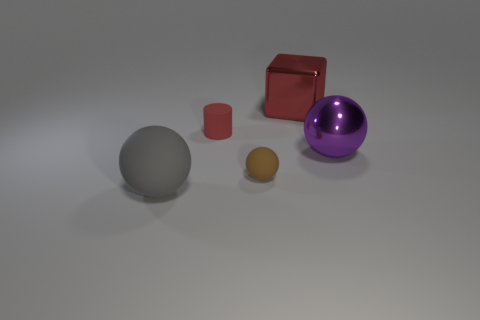Add 2 large brown rubber blocks. How many objects exist? 7 Subtract all spheres. How many objects are left? 2 Subtract 1 gray spheres. How many objects are left? 4 Subtract all large blue matte balls. Subtract all purple balls. How many objects are left? 4 Add 2 big matte things. How many big matte things are left? 3 Add 1 large blue rubber cylinders. How many large blue rubber cylinders exist? 1 